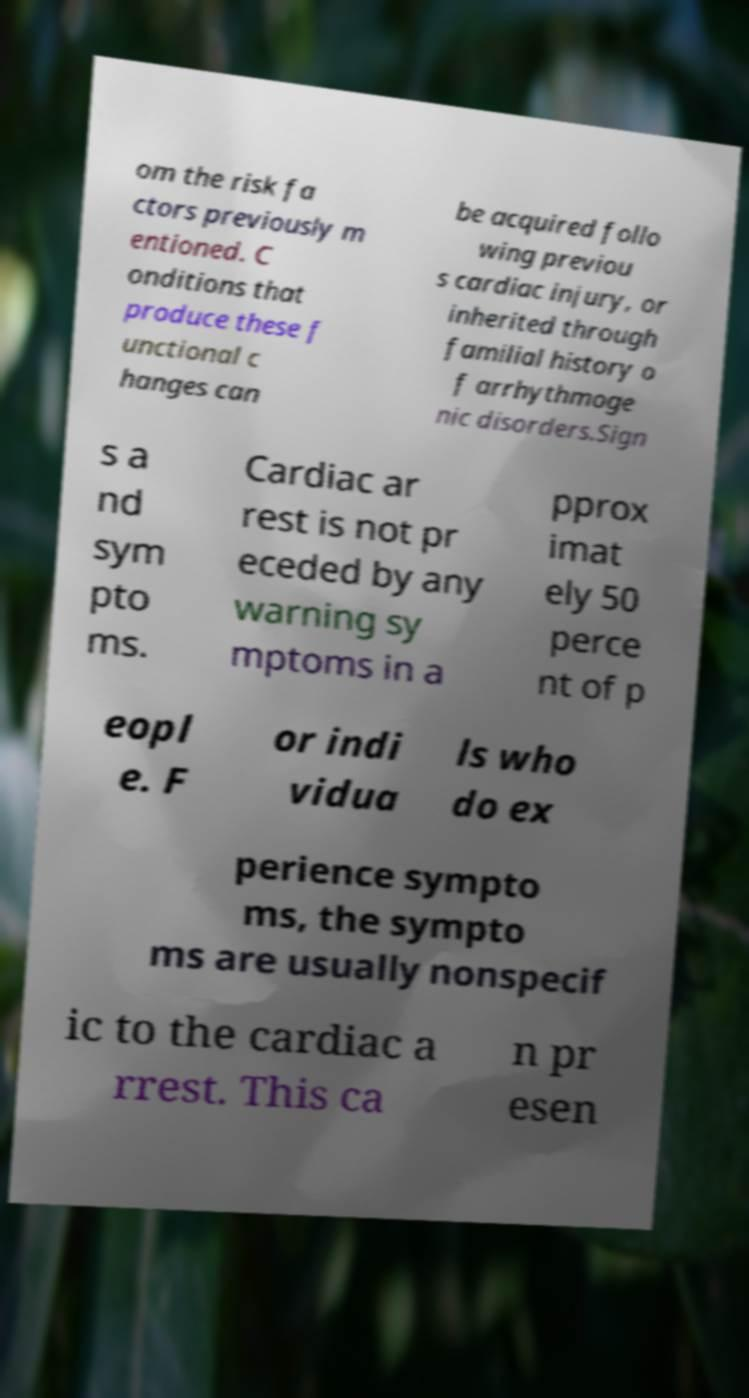There's text embedded in this image that I need extracted. Can you transcribe it verbatim? om the risk fa ctors previously m entioned. C onditions that produce these f unctional c hanges can be acquired follo wing previou s cardiac injury, or inherited through familial history o f arrhythmoge nic disorders.Sign s a nd sym pto ms. Cardiac ar rest is not pr eceded by any warning sy mptoms in a pprox imat ely 50 perce nt of p eopl e. F or indi vidua ls who do ex perience sympto ms, the sympto ms are usually nonspecif ic to the cardiac a rrest. This ca n pr esen 